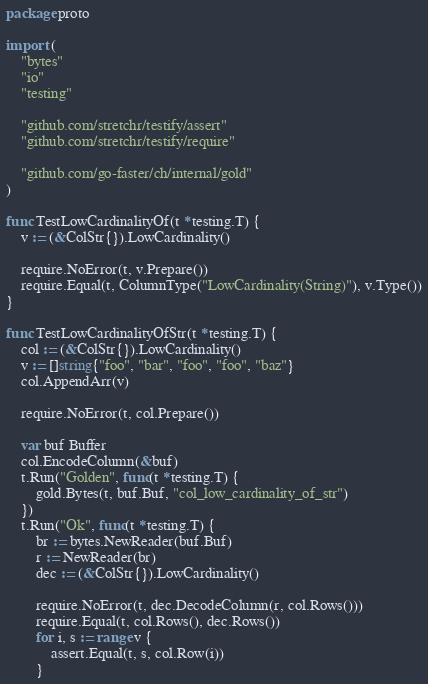<code> <loc_0><loc_0><loc_500><loc_500><_Go_>package proto

import (
	"bytes"
	"io"
	"testing"

	"github.com/stretchr/testify/assert"
	"github.com/stretchr/testify/require"

	"github.com/go-faster/ch/internal/gold"
)

func TestLowCardinalityOf(t *testing.T) {
	v := (&ColStr{}).LowCardinality()

	require.NoError(t, v.Prepare())
	require.Equal(t, ColumnType("LowCardinality(String)"), v.Type())
}

func TestLowCardinalityOfStr(t *testing.T) {
	col := (&ColStr{}).LowCardinality()
	v := []string{"foo", "bar", "foo", "foo", "baz"}
	col.AppendArr(v)

	require.NoError(t, col.Prepare())

	var buf Buffer
	col.EncodeColumn(&buf)
	t.Run("Golden", func(t *testing.T) {
		gold.Bytes(t, buf.Buf, "col_low_cardinality_of_str")
	})
	t.Run("Ok", func(t *testing.T) {
		br := bytes.NewReader(buf.Buf)
		r := NewReader(br)
		dec := (&ColStr{}).LowCardinality()

		require.NoError(t, dec.DecodeColumn(r, col.Rows()))
		require.Equal(t, col.Rows(), dec.Rows())
		for i, s := range v {
			assert.Equal(t, s, col.Row(i))
		}</code> 